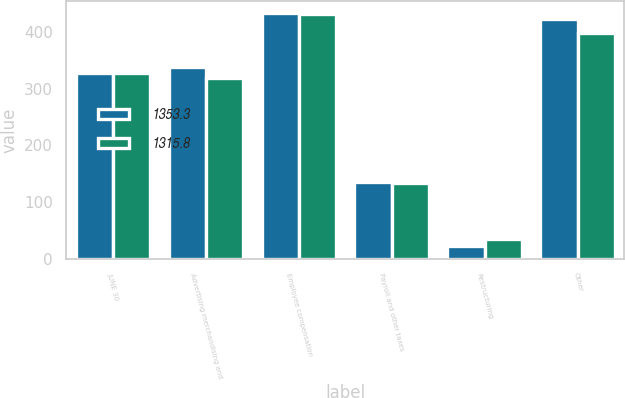<chart> <loc_0><loc_0><loc_500><loc_500><stacked_bar_chart><ecel><fcel>JUNE 30<fcel>Advertising merchandising and<fcel>Employee compensation<fcel>Payroll and other taxes<fcel>Restructuring<fcel>Other<nl><fcel>1353.3<fcel>328.5<fcel>338.4<fcel>433.3<fcel>135.7<fcel>23.2<fcel>422.7<nl><fcel>1315.8<fcel>328.5<fcel>318.6<fcel>431.4<fcel>133<fcel>34.8<fcel>398<nl></chart> 